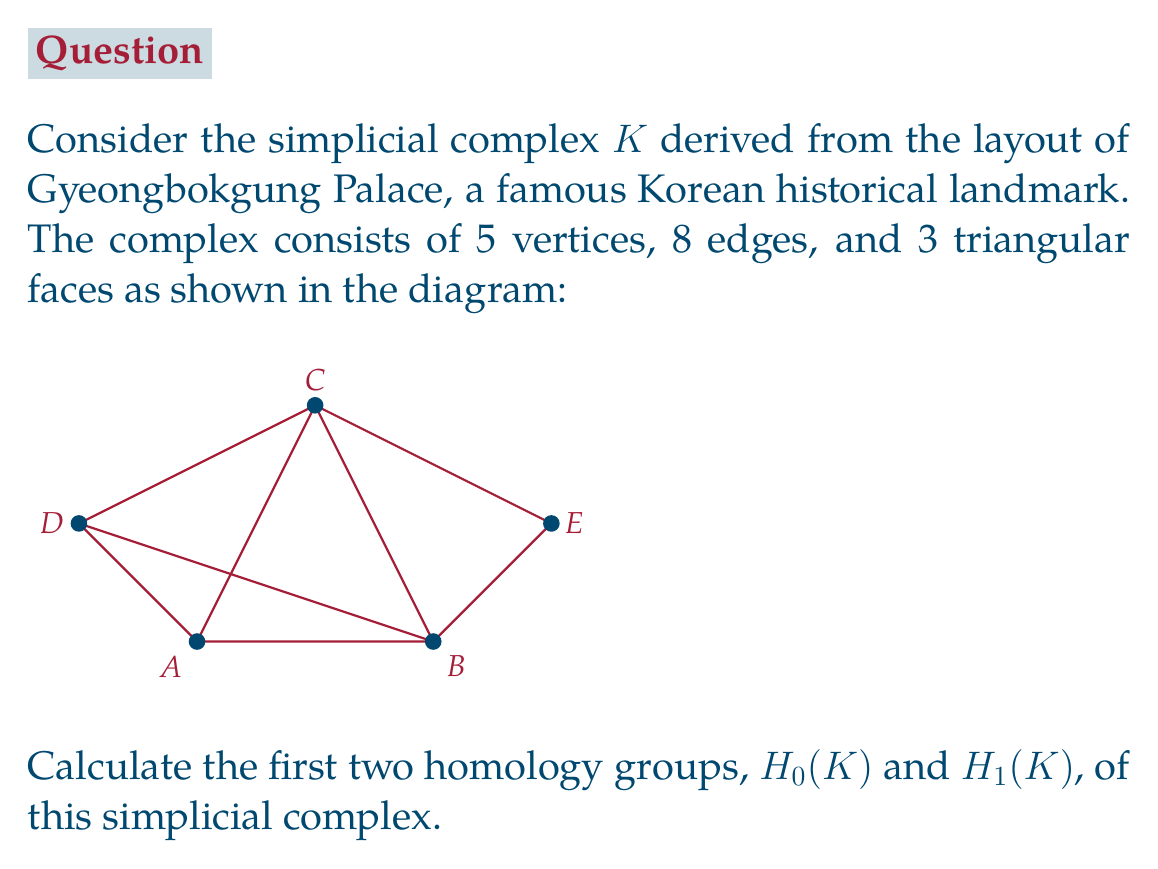Teach me how to tackle this problem. To calculate the homology groups, we'll follow these steps:

1) First, let's count the simplices:
   $n_0 = 5$ (vertices)
   $n_1 = 8$ (edges)
   $n_2 = 3$ (triangular faces)

2) Now, we need to calculate the ranks of the boundary maps:
   $\partial_2: C_2 \to C_1$ and $\partial_1: C_1 \to C_0$

3) For $\partial_2$, we have 3 triangles. The rank of this map is equal to the number of linearly independent columns in the boundary matrix, which is 3.

4) For $\partial_1$, we have 8 edges connecting 5 vertices. The rank of this map is 4, as it's the number of edges in a spanning tree of the complex.

5) Now we can calculate the Betti numbers:
   $\beta_0 = \text{dim ker }\partial_0 - \text{rank }\partial_1 = 5 - 4 = 1$
   $\beta_1 = \text{dim ker }\partial_1 - \text{rank }\partial_2 = (8 - 4) - 3 = 1$

6) The homology groups are:
   $H_0(K) \cong \mathbb{Z}^{\beta_0} \cong \mathbb{Z}$
   $H_1(K) \cong \mathbb{Z}^{\beta_1} \cong \mathbb{Z}$

The interpretation:
- $H_0(K) \cong \mathbb{Z}$ indicates that the complex is connected (one component).
- $H_1(K) \cong \mathbb{Z}$ indicates that there is one non-trivial 1-dimensional hole (cycle) in the complex.
Answer: $H_0(K) \cong \mathbb{Z}, H_1(K) \cong \mathbb{Z}$ 